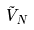<formula> <loc_0><loc_0><loc_500><loc_500>\tilde { V } _ { N }</formula> 